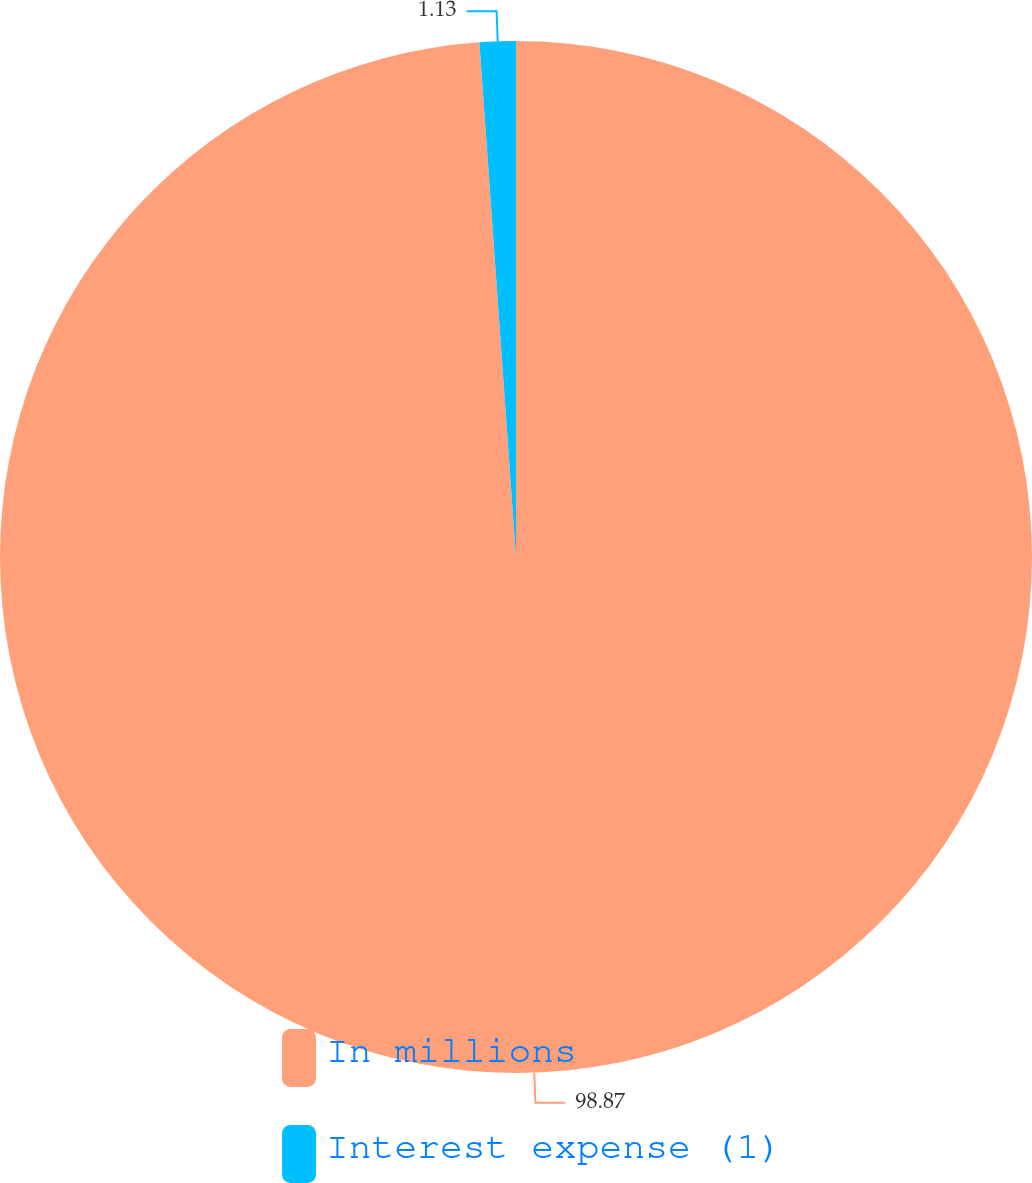<chart> <loc_0><loc_0><loc_500><loc_500><pie_chart><fcel>In millions<fcel>Interest expense (1)<nl><fcel>98.87%<fcel>1.13%<nl></chart> 